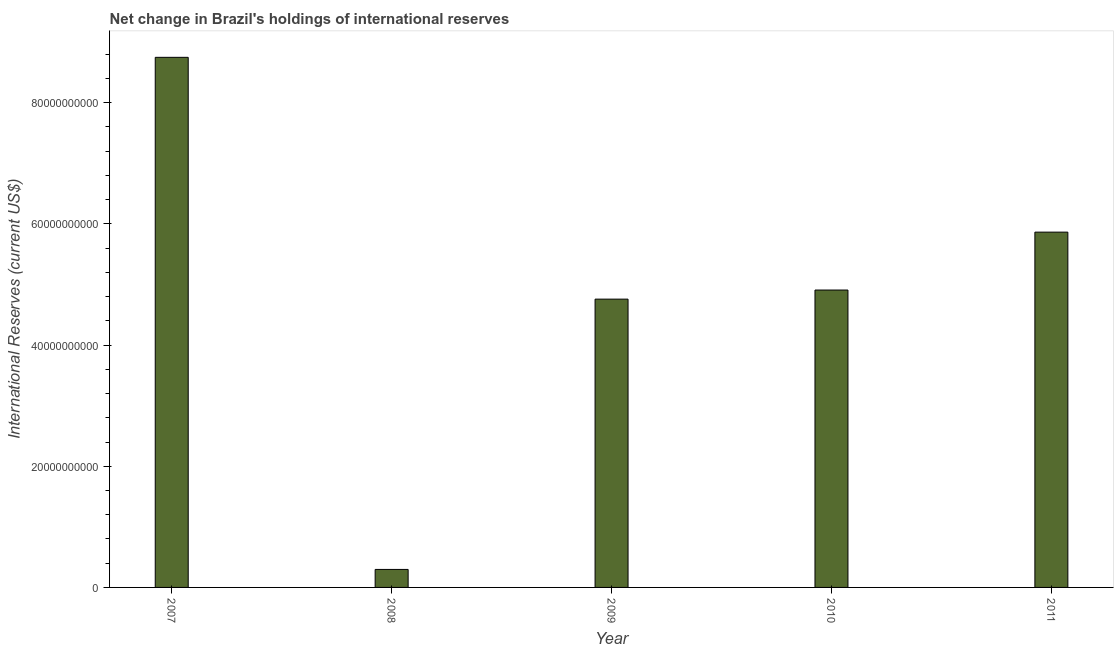Does the graph contain any zero values?
Keep it short and to the point. No. What is the title of the graph?
Provide a short and direct response. Net change in Brazil's holdings of international reserves. What is the label or title of the X-axis?
Provide a short and direct response. Year. What is the label or title of the Y-axis?
Make the answer very short. International Reserves (current US$). What is the reserves and related items in 2007?
Offer a very short reply. 8.75e+1. Across all years, what is the maximum reserves and related items?
Provide a succinct answer. 8.75e+1. Across all years, what is the minimum reserves and related items?
Offer a terse response. 2.97e+09. In which year was the reserves and related items minimum?
Make the answer very short. 2008. What is the sum of the reserves and related items?
Make the answer very short. 2.46e+11. What is the difference between the reserves and related items in 2008 and 2011?
Ensure brevity in your answer.  -5.57e+1. What is the average reserves and related items per year?
Keep it short and to the point. 4.91e+1. What is the median reserves and related items?
Give a very brief answer. 4.91e+1. In how many years, is the reserves and related items greater than 68000000000 US$?
Keep it short and to the point. 1. Do a majority of the years between 2007 and 2010 (inclusive) have reserves and related items greater than 24000000000 US$?
Provide a succinct answer. Yes. What is the ratio of the reserves and related items in 2008 to that in 2009?
Ensure brevity in your answer.  0.06. Is the reserves and related items in 2008 less than that in 2009?
Provide a short and direct response. Yes. What is the difference between the highest and the second highest reserves and related items?
Provide a short and direct response. 2.88e+1. Is the sum of the reserves and related items in 2007 and 2009 greater than the maximum reserves and related items across all years?
Keep it short and to the point. Yes. What is the difference between the highest and the lowest reserves and related items?
Offer a very short reply. 8.45e+1. In how many years, is the reserves and related items greater than the average reserves and related items taken over all years?
Keep it short and to the point. 2. Are all the bars in the graph horizontal?
Provide a short and direct response. No. What is the International Reserves (current US$) of 2007?
Make the answer very short. 8.75e+1. What is the International Reserves (current US$) of 2008?
Make the answer very short. 2.97e+09. What is the International Reserves (current US$) in 2009?
Your response must be concise. 4.76e+1. What is the International Reserves (current US$) of 2010?
Your response must be concise. 4.91e+1. What is the International Reserves (current US$) in 2011?
Your answer should be compact. 5.86e+1. What is the difference between the International Reserves (current US$) in 2007 and 2008?
Offer a terse response. 8.45e+1. What is the difference between the International Reserves (current US$) in 2007 and 2009?
Keep it short and to the point. 3.99e+1. What is the difference between the International Reserves (current US$) in 2007 and 2010?
Your answer should be compact. 3.84e+1. What is the difference between the International Reserves (current US$) in 2007 and 2011?
Offer a very short reply. 2.88e+1. What is the difference between the International Reserves (current US$) in 2008 and 2009?
Offer a terse response. -4.46e+1. What is the difference between the International Reserves (current US$) in 2008 and 2010?
Offer a very short reply. -4.61e+1. What is the difference between the International Reserves (current US$) in 2008 and 2011?
Keep it short and to the point. -5.57e+1. What is the difference between the International Reserves (current US$) in 2009 and 2010?
Provide a short and direct response. -1.50e+09. What is the difference between the International Reserves (current US$) in 2009 and 2011?
Ensure brevity in your answer.  -1.11e+1. What is the difference between the International Reserves (current US$) in 2010 and 2011?
Offer a terse response. -9.55e+09. What is the ratio of the International Reserves (current US$) in 2007 to that in 2008?
Keep it short and to the point. 29.46. What is the ratio of the International Reserves (current US$) in 2007 to that in 2009?
Your answer should be compact. 1.84. What is the ratio of the International Reserves (current US$) in 2007 to that in 2010?
Offer a terse response. 1.78. What is the ratio of the International Reserves (current US$) in 2007 to that in 2011?
Offer a terse response. 1.49. What is the ratio of the International Reserves (current US$) in 2008 to that in 2009?
Offer a very short reply. 0.06. What is the ratio of the International Reserves (current US$) in 2008 to that in 2010?
Make the answer very short. 0.06. What is the ratio of the International Reserves (current US$) in 2008 to that in 2011?
Keep it short and to the point. 0.05. What is the ratio of the International Reserves (current US$) in 2009 to that in 2011?
Give a very brief answer. 0.81. What is the ratio of the International Reserves (current US$) in 2010 to that in 2011?
Keep it short and to the point. 0.84. 